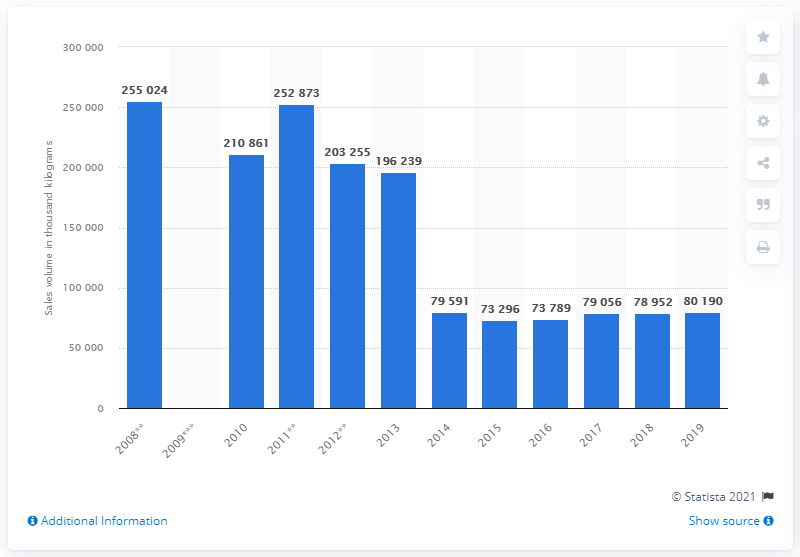Draw attention to some important aspects in this diagram. In 2019, the sales volume of margarine was 80,190 units. 